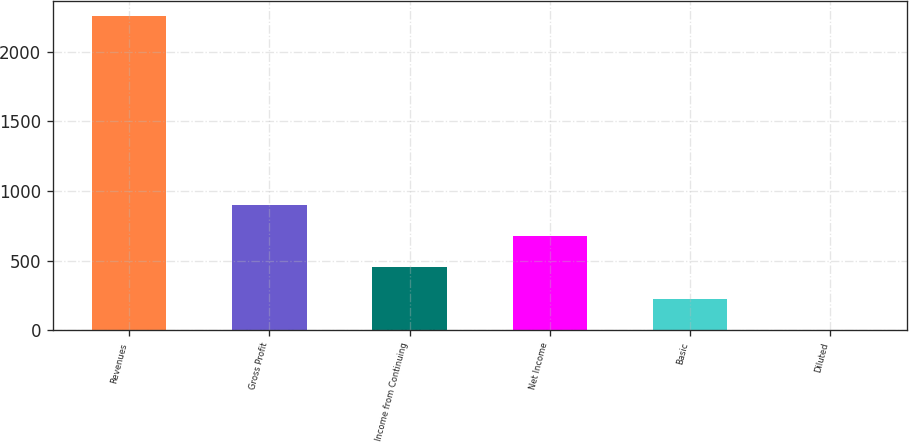Convert chart. <chart><loc_0><loc_0><loc_500><loc_500><bar_chart><fcel>Revenues<fcel>Gross Profit<fcel>Income from Continuing<fcel>Net Income<fcel>Basic<fcel>Diluted<nl><fcel>2255.1<fcel>902.26<fcel>451.31<fcel>676.79<fcel>225.83<fcel>0.35<nl></chart> 